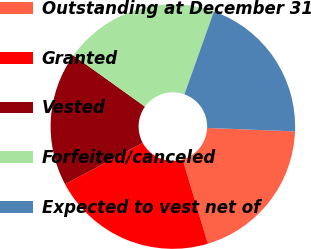<chart> <loc_0><loc_0><loc_500><loc_500><pie_chart><fcel>Outstanding at December 31<fcel>Granted<fcel>Vested<fcel>Forfeited/canceled<fcel>Expected to vest net of<nl><fcel>19.76%<fcel>21.79%<fcel>17.71%<fcel>20.57%<fcel>20.17%<nl></chart> 